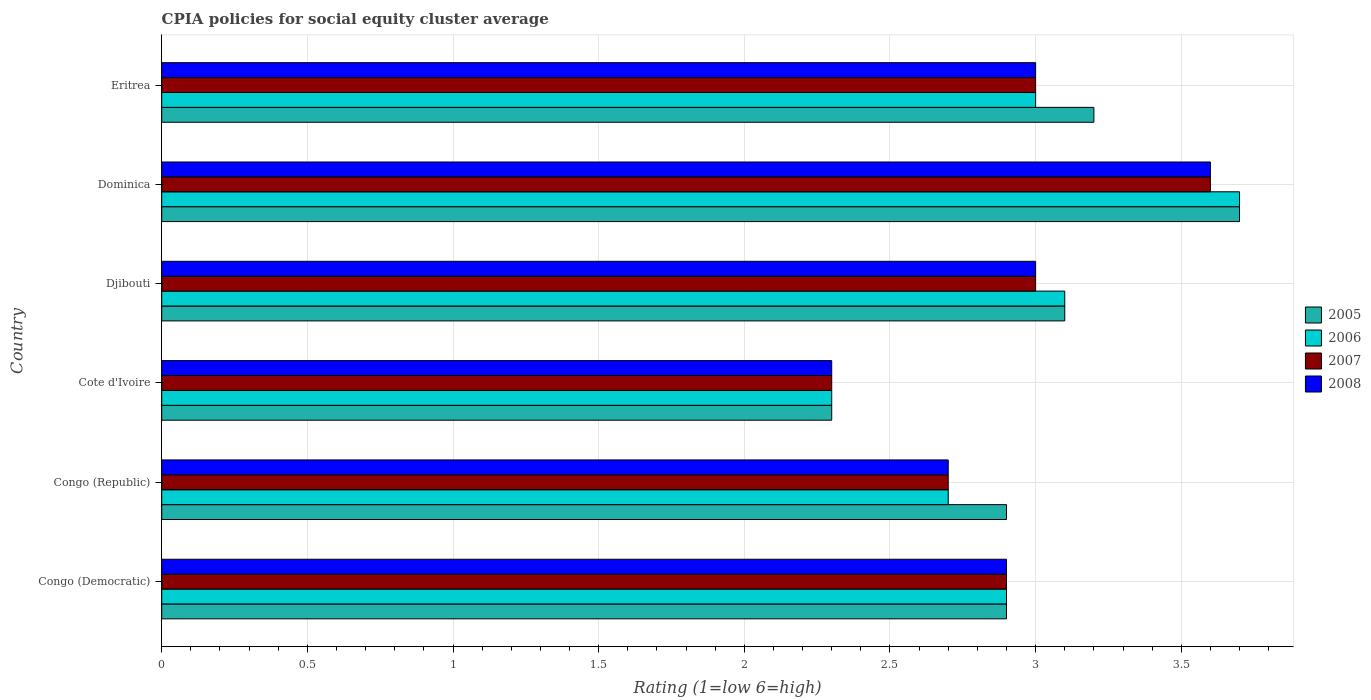How many different coloured bars are there?
Your answer should be very brief. 4. How many groups of bars are there?
Provide a short and direct response. 6. How many bars are there on the 5th tick from the top?
Your answer should be compact. 4. How many bars are there on the 2nd tick from the bottom?
Offer a very short reply. 4. What is the label of the 3rd group of bars from the top?
Provide a short and direct response. Djibouti. In how many cases, is the number of bars for a given country not equal to the number of legend labels?
Keep it short and to the point. 0. Across all countries, what is the maximum CPIA rating in 2008?
Offer a terse response. 3.6. Across all countries, what is the minimum CPIA rating in 2005?
Your response must be concise. 2.3. In which country was the CPIA rating in 2006 maximum?
Offer a terse response. Dominica. In which country was the CPIA rating in 2006 minimum?
Keep it short and to the point. Cote d'Ivoire. What is the total CPIA rating in 2007 in the graph?
Your response must be concise. 17.5. What is the difference between the CPIA rating in 2005 in Djibouti and that in Eritrea?
Ensure brevity in your answer.  -0.1. What is the difference between the CPIA rating in 2008 in Dominica and the CPIA rating in 2006 in Cote d'Ivoire?
Your answer should be very brief. 1.3. What is the average CPIA rating in 2005 per country?
Your answer should be compact. 3.02. What is the difference between the CPIA rating in 2005 and CPIA rating in 2008 in Eritrea?
Your answer should be compact. 0.2. In how many countries, is the CPIA rating in 2008 greater than 2.8 ?
Offer a very short reply. 4. What is the ratio of the CPIA rating in 2005 in Dominica to that in Eritrea?
Offer a terse response. 1.16. Is the CPIA rating in 2008 in Congo (Democratic) less than that in Djibouti?
Keep it short and to the point. Yes. What is the difference between the highest and the second highest CPIA rating in 2006?
Keep it short and to the point. 0.6. What is the difference between the highest and the lowest CPIA rating in 2005?
Keep it short and to the point. 1.4. In how many countries, is the CPIA rating in 2008 greater than the average CPIA rating in 2008 taken over all countries?
Keep it short and to the point. 3. What does the 2nd bar from the top in Congo (Democratic) represents?
Ensure brevity in your answer.  2007. What does the 2nd bar from the bottom in Cote d'Ivoire represents?
Keep it short and to the point. 2006. Does the graph contain grids?
Make the answer very short. Yes. How many legend labels are there?
Give a very brief answer. 4. What is the title of the graph?
Your answer should be very brief. CPIA policies for social equity cluster average. Does "2005" appear as one of the legend labels in the graph?
Offer a very short reply. Yes. What is the label or title of the Y-axis?
Make the answer very short. Country. What is the Rating (1=low 6=high) in 2006 in Congo (Democratic)?
Provide a short and direct response. 2.9. What is the Rating (1=low 6=high) of 2007 in Congo (Democratic)?
Ensure brevity in your answer.  2.9. What is the Rating (1=low 6=high) of 2008 in Congo (Democratic)?
Provide a succinct answer. 2.9. What is the Rating (1=low 6=high) of 2005 in Congo (Republic)?
Your answer should be compact. 2.9. What is the Rating (1=low 6=high) of 2006 in Congo (Republic)?
Your answer should be very brief. 2.7. What is the Rating (1=low 6=high) in 2005 in Cote d'Ivoire?
Your answer should be compact. 2.3. What is the Rating (1=low 6=high) in 2006 in Cote d'Ivoire?
Your answer should be compact. 2.3. What is the Rating (1=low 6=high) in 2007 in Djibouti?
Provide a short and direct response. 3. What is the Rating (1=low 6=high) in 2008 in Djibouti?
Keep it short and to the point. 3. What is the Rating (1=low 6=high) of 2005 in Dominica?
Keep it short and to the point. 3.7. What is the Rating (1=low 6=high) in 2006 in Dominica?
Offer a very short reply. 3.7. What is the Rating (1=low 6=high) in 2007 in Eritrea?
Give a very brief answer. 3. Across all countries, what is the maximum Rating (1=low 6=high) in 2008?
Offer a terse response. 3.6. Across all countries, what is the minimum Rating (1=low 6=high) in 2008?
Give a very brief answer. 2.3. What is the total Rating (1=low 6=high) of 2008 in the graph?
Ensure brevity in your answer.  17.5. What is the difference between the Rating (1=low 6=high) in 2005 in Congo (Democratic) and that in Congo (Republic)?
Keep it short and to the point. 0. What is the difference between the Rating (1=low 6=high) of 2007 in Congo (Democratic) and that in Congo (Republic)?
Offer a very short reply. 0.2. What is the difference between the Rating (1=low 6=high) of 2008 in Congo (Democratic) and that in Congo (Republic)?
Provide a short and direct response. 0.2. What is the difference between the Rating (1=low 6=high) of 2006 in Congo (Democratic) and that in Cote d'Ivoire?
Make the answer very short. 0.6. What is the difference between the Rating (1=low 6=high) of 2005 in Congo (Democratic) and that in Djibouti?
Make the answer very short. -0.2. What is the difference between the Rating (1=low 6=high) of 2008 in Congo (Democratic) and that in Djibouti?
Provide a succinct answer. -0.1. What is the difference between the Rating (1=low 6=high) of 2005 in Congo (Democratic) and that in Dominica?
Give a very brief answer. -0.8. What is the difference between the Rating (1=low 6=high) in 2008 in Congo (Democratic) and that in Dominica?
Provide a short and direct response. -0.7. What is the difference between the Rating (1=low 6=high) in 2005 in Congo (Democratic) and that in Eritrea?
Your answer should be compact. -0.3. What is the difference between the Rating (1=low 6=high) of 2007 in Congo (Democratic) and that in Eritrea?
Offer a terse response. -0.1. What is the difference between the Rating (1=low 6=high) of 2008 in Congo (Democratic) and that in Eritrea?
Ensure brevity in your answer.  -0.1. What is the difference between the Rating (1=low 6=high) of 2006 in Congo (Republic) and that in Cote d'Ivoire?
Keep it short and to the point. 0.4. What is the difference between the Rating (1=low 6=high) in 2007 in Congo (Republic) and that in Cote d'Ivoire?
Your response must be concise. 0.4. What is the difference between the Rating (1=low 6=high) in 2008 in Congo (Republic) and that in Cote d'Ivoire?
Keep it short and to the point. 0.4. What is the difference between the Rating (1=low 6=high) of 2005 in Congo (Republic) and that in Djibouti?
Your response must be concise. -0.2. What is the difference between the Rating (1=low 6=high) in 2007 in Congo (Republic) and that in Djibouti?
Offer a terse response. -0.3. What is the difference between the Rating (1=low 6=high) in 2005 in Congo (Republic) and that in Dominica?
Your response must be concise. -0.8. What is the difference between the Rating (1=low 6=high) in 2006 in Congo (Republic) and that in Dominica?
Your response must be concise. -1. What is the difference between the Rating (1=low 6=high) of 2008 in Congo (Republic) and that in Dominica?
Provide a short and direct response. -0.9. What is the difference between the Rating (1=low 6=high) in 2005 in Congo (Republic) and that in Eritrea?
Offer a terse response. -0.3. What is the difference between the Rating (1=low 6=high) in 2008 in Congo (Republic) and that in Eritrea?
Make the answer very short. -0.3. What is the difference between the Rating (1=low 6=high) in 2007 in Cote d'Ivoire and that in Djibouti?
Offer a very short reply. -0.7. What is the difference between the Rating (1=low 6=high) in 2005 in Cote d'Ivoire and that in Eritrea?
Your answer should be very brief. -0.9. What is the difference between the Rating (1=low 6=high) in 2006 in Cote d'Ivoire and that in Eritrea?
Your answer should be compact. -0.7. What is the difference between the Rating (1=low 6=high) in 2007 in Djibouti and that in Dominica?
Provide a succinct answer. -0.6. What is the difference between the Rating (1=low 6=high) of 2007 in Djibouti and that in Eritrea?
Make the answer very short. 0. What is the difference between the Rating (1=low 6=high) of 2005 in Dominica and that in Eritrea?
Provide a succinct answer. 0.5. What is the difference between the Rating (1=low 6=high) in 2008 in Dominica and that in Eritrea?
Your answer should be very brief. 0.6. What is the difference between the Rating (1=low 6=high) in 2005 in Congo (Democratic) and the Rating (1=low 6=high) in 2007 in Congo (Republic)?
Your response must be concise. 0.2. What is the difference between the Rating (1=low 6=high) in 2005 in Congo (Democratic) and the Rating (1=low 6=high) in 2008 in Congo (Republic)?
Your response must be concise. 0.2. What is the difference between the Rating (1=low 6=high) in 2007 in Congo (Democratic) and the Rating (1=low 6=high) in 2008 in Congo (Republic)?
Offer a terse response. 0.2. What is the difference between the Rating (1=low 6=high) of 2005 in Congo (Democratic) and the Rating (1=low 6=high) of 2008 in Cote d'Ivoire?
Give a very brief answer. 0.6. What is the difference between the Rating (1=low 6=high) of 2006 in Congo (Democratic) and the Rating (1=low 6=high) of 2008 in Cote d'Ivoire?
Provide a succinct answer. 0.6. What is the difference between the Rating (1=low 6=high) of 2007 in Congo (Democratic) and the Rating (1=low 6=high) of 2008 in Cote d'Ivoire?
Ensure brevity in your answer.  0.6. What is the difference between the Rating (1=low 6=high) of 2005 in Congo (Democratic) and the Rating (1=low 6=high) of 2006 in Djibouti?
Your answer should be compact. -0.2. What is the difference between the Rating (1=low 6=high) of 2005 in Congo (Democratic) and the Rating (1=low 6=high) of 2008 in Djibouti?
Offer a very short reply. -0.1. What is the difference between the Rating (1=low 6=high) of 2006 in Congo (Democratic) and the Rating (1=low 6=high) of 2007 in Djibouti?
Make the answer very short. -0.1. What is the difference between the Rating (1=low 6=high) of 2006 in Congo (Democratic) and the Rating (1=low 6=high) of 2008 in Djibouti?
Provide a short and direct response. -0.1. What is the difference between the Rating (1=low 6=high) in 2007 in Congo (Democratic) and the Rating (1=low 6=high) in 2008 in Djibouti?
Make the answer very short. -0.1. What is the difference between the Rating (1=low 6=high) in 2005 in Congo (Democratic) and the Rating (1=low 6=high) in 2007 in Dominica?
Ensure brevity in your answer.  -0.7. What is the difference between the Rating (1=low 6=high) of 2007 in Congo (Democratic) and the Rating (1=low 6=high) of 2008 in Dominica?
Ensure brevity in your answer.  -0.7. What is the difference between the Rating (1=low 6=high) of 2005 in Congo (Democratic) and the Rating (1=low 6=high) of 2007 in Eritrea?
Provide a short and direct response. -0.1. What is the difference between the Rating (1=low 6=high) in 2006 in Congo (Democratic) and the Rating (1=low 6=high) in 2007 in Eritrea?
Your answer should be very brief. -0.1. What is the difference between the Rating (1=low 6=high) in 2006 in Congo (Democratic) and the Rating (1=low 6=high) in 2008 in Eritrea?
Keep it short and to the point. -0.1. What is the difference between the Rating (1=low 6=high) in 2005 in Congo (Republic) and the Rating (1=low 6=high) in 2007 in Cote d'Ivoire?
Keep it short and to the point. 0.6. What is the difference between the Rating (1=low 6=high) in 2005 in Congo (Republic) and the Rating (1=low 6=high) in 2008 in Cote d'Ivoire?
Offer a very short reply. 0.6. What is the difference between the Rating (1=low 6=high) of 2006 in Congo (Republic) and the Rating (1=low 6=high) of 2007 in Cote d'Ivoire?
Ensure brevity in your answer.  0.4. What is the difference between the Rating (1=low 6=high) in 2005 in Congo (Republic) and the Rating (1=low 6=high) in 2006 in Djibouti?
Ensure brevity in your answer.  -0.2. What is the difference between the Rating (1=low 6=high) in 2005 in Congo (Republic) and the Rating (1=low 6=high) in 2007 in Djibouti?
Offer a very short reply. -0.1. What is the difference between the Rating (1=low 6=high) of 2006 in Congo (Republic) and the Rating (1=low 6=high) of 2008 in Djibouti?
Your answer should be compact. -0.3. What is the difference between the Rating (1=low 6=high) in 2005 in Congo (Republic) and the Rating (1=low 6=high) in 2007 in Dominica?
Provide a succinct answer. -0.7. What is the difference between the Rating (1=low 6=high) in 2007 in Congo (Republic) and the Rating (1=low 6=high) in 2008 in Dominica?
Offer a very short reply. -0.9. What is the difference between the Rating (1=low 6=high) in 2005 in Congo (Republic) and the Rating (1=low 6=high) in 2006 in Eritrea?
Provide a short and direct response. -0.1. What is the difference between the Rating (1=low 6=high) of 2005 in Congo (Republic) and the Rating (1=low 6=high) of 2007 in Eritrea?
Ensure brevity in your answer.  -0.1. What is the difference between the Rating (1=low 6=high) in 2005 in Congo (Republic) and the Rating (1=low 6=high) in 2008 in Eritrea?
Provide a short and direct response. -0.1. What is the difference between the Rating (1=low 6=high) in 2005 in Cote d'Ivoire and the Rating (1=low 6=high) in 2008 in Djibouti?
Give a very brief answer. -0.7. What is the difference between the Rating (1=low 6=high) of 2006 in Cote d'Ivoire and the Rating (1=low 6=high) of 2008 in Djibouti?
Your response must be concise. -0.7. What is the difference between the Rating (1=low 6=high) in 2007 in Cote d'Ivoire and the Rating (1=low 6=high) in 2008 in Djibouti?
Offer a terse response. -0.7. What is the difference between the Rating (1=low 6=high) of 2005 in Cote d'Ivoire and the Rating (1=low 6=high) of 2006 in Dominica?
Keep it short and to the point. -1.4. What is the difference between the Rating (1=low 6=high) in 2005 in Cote d'Ivoire and the Rating (1=low 6=high) in 2007 in Dominica?
Offer a very short reply. -1.3. What is the difference between the Rating (1=low 6=high) of 2005 in Cote d'Ivoire and the Rating (1=low 6=high) of 2008 in Eritrea?
Ensure brevity in your answer.  -0.7. What is the difference between the Rating (1=low 6=high) in 2006 in Cote d'Ivoire and the Rating (1=low 6=high) in 2008 in Eritrea?
Your response must be concise. -0.7. What is the difference between the Rating (1=low 6=high) of 2005 in Djibouti and the Rating (1=low 6=high) of 2006 in Dominica?
Give a very brief answer. -0.6. What is the difference between the Rating (1=low 6=high) of 2005 in Djibouti and the Rating (1=low 6=high) of 2007 in Dominica?
Provide a succinct answer. -0.5. What is the difference between the Rating (1=low 6=high) of 2005 in Djibouti and the Rating (1=low 6=high) of 2008 in Dominica?
Give a very brief answer. -0.5. What is the difference between the Rating (1=low 6=high) of 2006 in Djibouti and the Rating (1=low 6=high) of 2007 in Dominica?
Provide a succinct answer. -0.5. What is the difference between the Rating (1=low 6=high) in 2006 in Djibouti and the Rating (1=low 6=high) in 2008 in Dominica?
Make the answer very short. -0.5. What is the difference between the Rating (1=low 6=high) of 2005 in Djibouti and the Rating (1=low 6=high) of 2006 in Eritrea?
Give a very brief answer. 0.1. What is the difference between the Rating (1=low 6=high) of 2007 in Djibouti and the Rating (1=low 6=high) of 2008 in Eritrea?
Your answer should be compact. 0. What is the difference between the Rating (1=low 6=high) of 2005 in Dominica and the Rating (1=low 6=high) of 2006 in Eritrea?
Offer a very short reply. 0.7. What is the difference between the Rating (1=low 6=high) of 2005 in Dominica and the Rating (1=low 6=high) of 2008 in Eritrea?
Your answer should be compact. 0.7. What is the difference between the Rating (1=low 6=high) in 2007 in Dominica and the Rating (1=low 6=high) in 2008 in Eritrea?
Your response must be concise. 0.6. What is the average Rating (1=low 6=high) of 2005 per country?
Keep it short and to the point. 3.02. What is the average Rating (1=low 6=high) in 2006 per country?
Keep it short and to the point. 2.95. What is the average Rating (1=low 6=high) of 2007 per country?
Ensure brevity in your answer.  2.92. What is the average Rating (1=low 6=high) in 2008 per country?
Provide a short and direct response. 2.92. What is the difference between the Rating (1=low 6=high) in 2005 and Rating (1=low 6=high) in 2006 in Congo (Democratic)?
Your response must be concise. 0. What is the difference between the Rating (1=low 6=high) of 2005 and Rating (1=low 6=high) of 2006 in Congo (Republic)?
Your answer should be very brief. 0.2. What is the difference between the Rating (1=low 6=high) of 2005 and Rating (1=low 6=high) of 2007 in Congo (Republic)?
Provide a succinct answer. 0.2. What is the difference between the Rating (1=low 6=high) in 2005 and Rating (1=low 6=high) in 2008 in Congo (Republic)?
Your answer should be compact. 0.2. What is the difference between the Rating (1=low 6=high) of 2006 and Rating (1=low 6=high) of 2008 in Congo (Republic)?
Offer a terse response. 0. What is the difference between the Rating (1=low 6=high) in 2007 and Rating (1=low 6=high) in 2008 in Congo (Republic)?
Provide a succinct answer. 0. What is the difference between the Rating (1=low 6=high) of 2005 and Rating (1=low 6=high) of 2006 in Cote d'Ivoire?
Provide a short and direct response. 0. What is the difference between the Rating (1=low 6=high) of 2005 and Rating (1=low 6=high) of 2007 in Cote d'Ivoire?
Provide a short and direct response. 0. What is the difference between the Rating (1=low 6=high) of 2005 and Rating (1=low 6=high) of 2008 in Cote d'Ivoire?
Keep it short and to the point. 0. What is the difference between the Rating (1=low 6=high) of 2005 and Rating (1=low 6=high) of 2008 in Djibouti?
Your answer should be very brief. 0.1. What is the difference between the Rating (1=low 6=high) of 2005 and Rating (1=low 6=high) of 2006 in Dominica?
Offer a terse response. 0. What is the difference between the Rating (1=low 6=high) of 2005 and Rating (1=low 6=high) of 2007 in Dominica?
Your response must be concise. 0.1. What is the difference between the Rating (1=low 6=high) of 2005 and Rating (1=low 6=high) of 2008 in Dominica?
Offer a very short reply. 0.1. What is the difference between the Rating (1=low 6=high) of 2006 and Rating (1=low 6=high) of 2007 in Dominica?
Ensure brevity in your answer.  0.1. What is the difference between the Rating (1=low 6=high) in 2006 and Rating (1=low 6=high) in 2008 in Dominica?
Ensure brevity in your answer.  0.1. What is the difference between the Rating (1=low 6=high) in 2007 and Rating (1=low 6=high) in 2008 in Dominica?
Offer a very short reply. 0. What is the difference between the Rating (1=low 6=high) in 2005 and Rating (1=low 6=high) in 2007 in Eritrea?
Your answer should be compact. 0.2. What is the difference between the Rating (1=low 6=high) in 2005 and Rating (1=low 6=high) in 2008 in Eritrea?
Offer a terse response. 0.2. What is the difference between the Rating (1=low 6=high) in 2006 and Rating (1=low 6=high) in 2008 in Eritrea?
Offer a terse response. 0. What is the difference between the Rating (1=low 6=high) in 2007 and Rating (1=low 6=high) in 2008 in Eritrea?
Your answer should be compact. 0. What is the ratio of the Rating (1=low 6=high) in 2005 in Congo (Democratic) to that in Congo (Republic)?
Your response must be concise. 1. What is the ratio of the Rating (1=low 6=high) in 2006 in Congo (Democratic) to that in Congo (Republic)?
Provide a succinct answer. 1.07. What is the ratio of the Rating (1=low 6=high) of 2007 in Congo (Democratic) to that in Congo (Republic)?
Make the answer very short. 1.07. What is the ratio of the Rating (1=low 6=high) in 2008 in Congo (Democratic) to that in Congo (Republic)?
Make the answer very short. 1.07. What is the ratio of the Rating (1=low 6=high) of 2005 in Congo (Democratic) to that in Cote d'Ivoire?
Provide a short and direct response. 1.26. What is the ratio of the Rating (1=low 6=high) in 2006 in Congo (Democratic) to that in Cote d'Ivoire?
Ensure brevity in your answer.  1.26. What is the ratio of the Rating (1=low 6=high) in 2007 in Congo (Democratic) to that in Cote d'Ivoire?
Give a very brief answer. 1.26. What is the ratio of the Rating (1=low 6=high) of 2008 in Congo (Democratic) to that in Cote d'Ivoire?
Keep it short and to the point. 1.26. What is the ratio of the Rating (1=low 6=high) in 2005 in Congo (Democratic) to that in Djibouti?
Provide a succinct answer. 0.94. What is the ratio of the Rating (1=low 6=high) in 2006 in Congo (Democratic) to that in Djibouti?
Offer a very short reply. 0.94. What is the ratio of the Rating (1=low 6=high) of 2007 in Congo (Democratic) to that in Djibouti?
Ensure brevity in your answer.  0.97. What is the ratio of the Rating (1=low 6=high) of 2008 in Congo (Democratic) to that in Djibouti?
Provide a succinct answer. 0.97. What is the ratio of the Rating (1=low 6=high) of 2005 in Congo (Democratic) to that in Dominica?
Your answer should be very brief. 0.78. What is the ratio of the Rating (1=low 6=high) of 2006 in Congo (Democratic) to that in Dominica?
Give a very brief answer. 0.78. What is the ratio of the Rating (1=low 6=high) in 2007 in Congo (Democratic) to that in Dominica?
Keep it short and to the point. 0.81. What is the ratio of the Rating (1=low 6=high) in 2008 in Congo (Democratic) to that in Dominica?
Provide a succinct answer. 0.81. What is the ratio of the Rating (1=low 6=high) of 2005 in Congo (Democratic) to that in Eritrea?
Provide a succinct answer. 0.91. What is the ratio of the Rating (1=low 6=high) of 2006 in Congo (Democratic) to that in Eritrea?
Your answer should be very brief. 0.97. What is the ratio of the Rating (1=low 6=high) of 2007 in Congo (Democratic) to that in Eritrea?
Your answer should be compact. 0.97. What is the ratio of the Rating (1=low 6=high) in 2008 in Congo (Democratic) to that in Eritrea?
Offer a terse response. 0.97. What is the ratio of the Rating (1=low 6=high) of 2005 in Congo (Republic) to that in Cote d'Ivoire?
Give a very brief answer. 1.26. What is the ratio of the Rating (1=low 6=high) of 2006 in Congo (Republic) to that in Cote d'Ivoire?
Make the answer very short. 1.17. What is the ratio of the Rating (1=low 6=high) in 2007 in Congo (Republic) to that in Cote d'Ivoire?
Give a very brief answer. 1.17. What is the ratio of the Rating (1=low 6=high) in 2008 in Congo (Republic) to that in Cote d'Ivoire?
Provide a short and direct response. 1.17. What is the ratio of the Rating (1=low 6=high) in 2005 in Congo (Republic) to that in Djibouti?
Ensure brevity in your answer.  0.94. What is the ratio of the Rating (1=low 6=high) in 2006 in Congo (Republic) to that in Djibouti?
Give a very brief answer. 0.87. What is the ratio of the Rating (1=low 6=high) of 2005 in Congo (Republic) to that in Dominica?
Ensure brevity in your answer.  0.78. What is the ratio of the Rating (1=low 6=high) in 2006 in Congo (Republic) to that in Dominica?
Your answer should be very brief. 0.73. What is the ratio of the Rating (1=low 6=high) of 2007 in Congo (Republic) to that in Dominica?
Ensure brevity in your answer.  0.75. What is the ratio of the Rating (1=low 6=high) of 2005 in Congo (Republic) to that in Eritrea?
Offer a terse response. 0.91. What is the ratio of the Rating (1=low 6=high) in 2007 in Congo (Republic) to that in Eritrea?
Your answer should be compact. 0.9. What is the ratio of the Rating (1=low 6=high) in 2008 in Congo (Republic) to that in Eritrea?
Ensure brevity in your answer.  0.9. What is the ratio of the Rating (1=low 6=high) of 2005 in Cote d'Ivoire to that in Djibouti?
Offer a very short reply. 0.74. What is the ratio of the Rating (1=low 6=high) of 2006 in Cote d'Ivoire to that in Djibouti?
Keep it short and to the point. 0.74. What is the ratio of the Rating (1=low 6=high) in 2007 in Cote d'Ivoire to that in Djibouti?
Ensure brevity in your answer.  0.77. What is the ratio of the Rating (1=low 6=high) of 2008 in Cote d'Ivoire to that in Djibouti?
Offer a terse response. 0.77. What is the ratio of the Rating (1=low 6=high) of 2005 in Cote d'Ivoire to that in Dominica?
Your answer should be very brief. 0.62. What is the ratio of the Rating (1=low 6=high) in 2006 in Cote d'Ivoire to that in Dominica?
Your answer should be compact. 0.62. What is the ratio of the Rating (1=low 6=high) of 2007 in Cote d'Ivoire to that in Dominica?
Your response must be concise. 0.64. What is the ratio of the Rating (1=low 6=high) in 2008 in Cote d'Ivoire to that in Dominica?
Your answer should be very brief. 0.64. What is the ratio of the Rating (1=low 6=high) of 2005 in Cote d'Ivoire to that in Eritrea?
Offer a terse response. 0.72. What is the ratio of the Rating (1=low 6=high) in 2006 in Cote d'Ivoire to that in Eritrea?
Provide a succinct answer. 0.77. What is the ratio of the Rating (1=low 6=high) in 2007 in Cote d'Ivoire to that in Eritrea?
Offer a very short reply. 0.77. What is the ratio of the Rating (1=low 6=high) in 2008 in Cote d'Ivoire to that in Eritrea?
Ensure brevity in your answer.  0.77. What is the ratio of the Rating (1=low 6=high) in 2005 in Djibouti to that in Dominica?
Offer a very short reply. 0.84. What is the ratio of the Rating (1=low 6=high) in 2006 in Djibouti to that in Dominica?
Your answer should be very brief. 0.84. What is the ratio of the Rating (1=low 6=high) of 2008 in Djibouti to that in Dominica?
Your answer should be compact. 0.83. What is the ratio of the Rating (1=low 6=high) in 2005 in Djibouti to that in Eritrea?
Make the answer very short. 0.97. What is the ratio of the Rating (1=low 6=high) in 2005 in Dominica to that in Eritrea?
Your response must be concise. 1.16. What is the ratio of the Rating (1=low 6=high) of 2006 in Dominica to that in Eritrea?
Offer a terse response. 1.23. What is the difference between the highest and the second highest Rating (1=low 6=high) of 2005?
Ensure brevity in your answer.  0.5. What is the difference between the highest and the second highest Rating (1=low 6=high) in 2006?
Your response must be concise. 0.6. What is the difference between the highest and the second highest Rating (1=low 6=high) in 2008?
Ensure brevity in your answer.  0.6. What is the difference between the highest and the lowest Rating (1=low 6=high) of 2005?
Your answer should be very brief. 1.4. What is the difference between the highest and the lowest Rating (1=low 6=high) of 2006?
Give a very brief answer. 1.4. What is the difference between the highest and the lowest Rating (1=low 6=high) in 2007?
Ensure brevity in your answer.  1.3. 